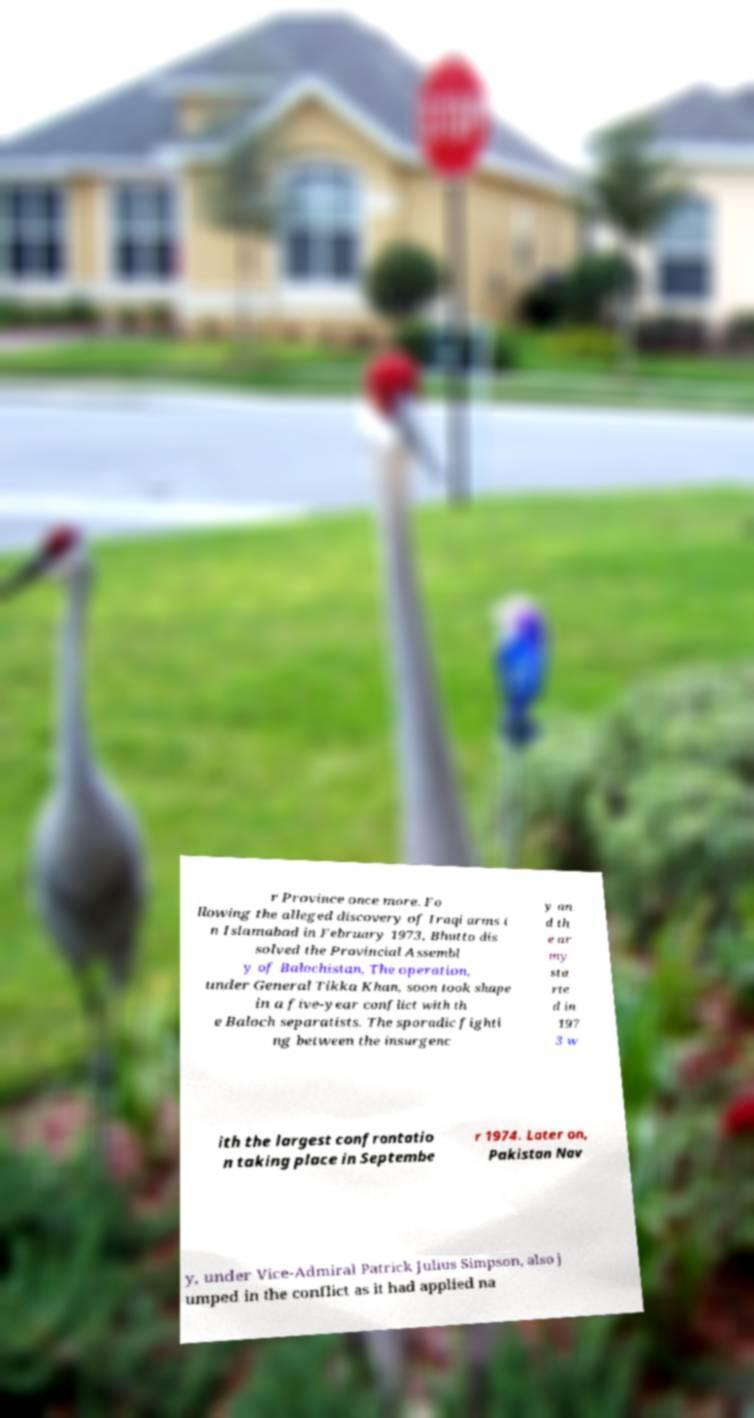I need the written content from this picture converted into text. Can you do that? r Province once more. Fo llowing the alleged discovery of Iraqi arms i n Islamabad in February 1973, Bhutto dis solved the Provincial Assembl y of Balochistan. The operation, under General Tikka Khan, soon took shape in a five-year conflict with th e Baloch separatists. The sporadic fighti ng between the insurgenc y an d th e ar my sta rte d in 197 3 w ith the largest confrontatio n taking place in Septembe r 1974. Later on, Pakistan Nav y, under Vice-Admiral Patrick Julius Simpson, also j umped in the conflict as it had applied na 